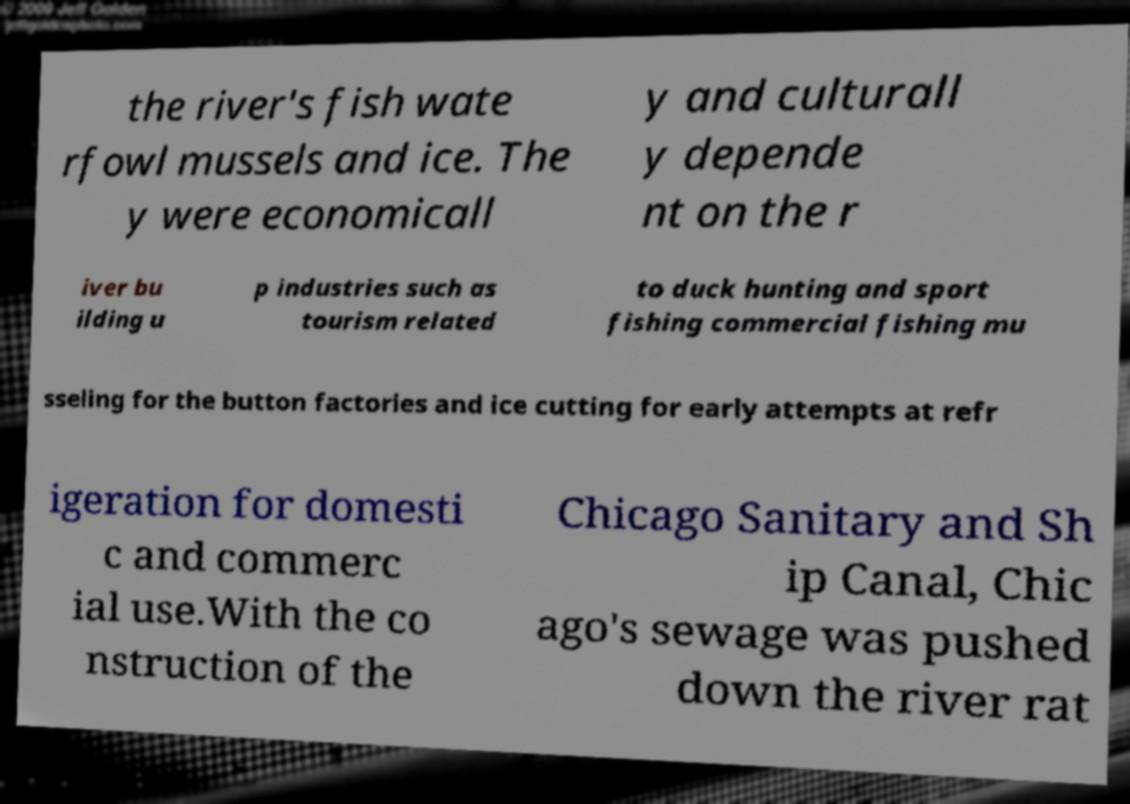Can you accurately transcribe the text from the provided image for me? the river's fish wate rfowl mussels and ice. The y were economicall y and culturall y depende nt on the r iver bu ilding u p industries such as tourism related to duck hunting and sport fishing commercial fishing mu sseling for the button factories and ice cutting for early attempts at refr igeration for domesti c and commerc ial use.With the co nstruction of the Chicago Sanitary and Sh ip Canal, Chic ago's sewage was pushed down the river rat 